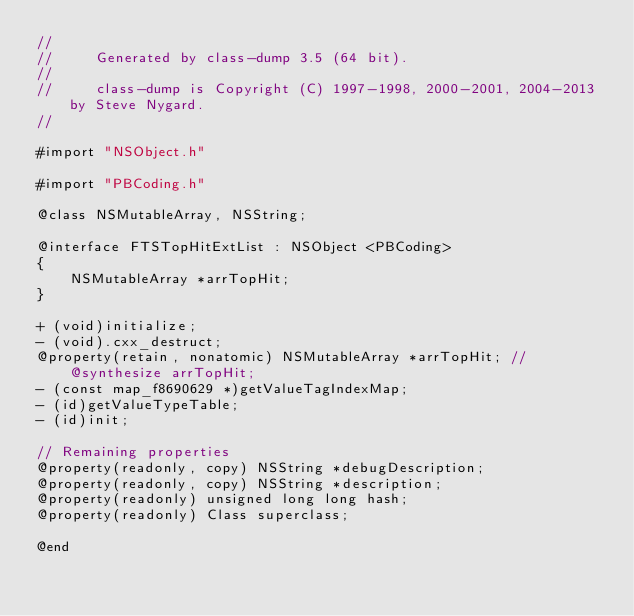<code> <loc_0><loc_0><loc_500><loc_500><_C_>//
//     Generated by class-dump 3.5 (64 bit).
//
//     class-dump is Copyright (C) 1997-1998, 2000-2001, 2004-2013 by Steve Nygard.
//

#import "NSObject.h"

#import "PBCoding.h"

@class NSMutableArray, NSString;

@interface FTSTopHitExtList : NSObject <PBCoding>
{
    NSMutableArray *arrTopHit;
}

+ (void)initialize;
- (void).cxx_destruct;
@property(retain, nonatomic) NSMutableArray *arrTopHit; // @synthesize arrTopHit;
- (const map_f8690629 *)getValueTagIndexMap;
- (id)getValueTypeTable;
- (id)init;

// Remaining properties
@property(readonly, copy) NSString *debugDescription;
@property(readonly, copy) NSString *description;
@property(readonly) unsigned long long hash;
@property(readonly) Class superclass;

@end

</code> 